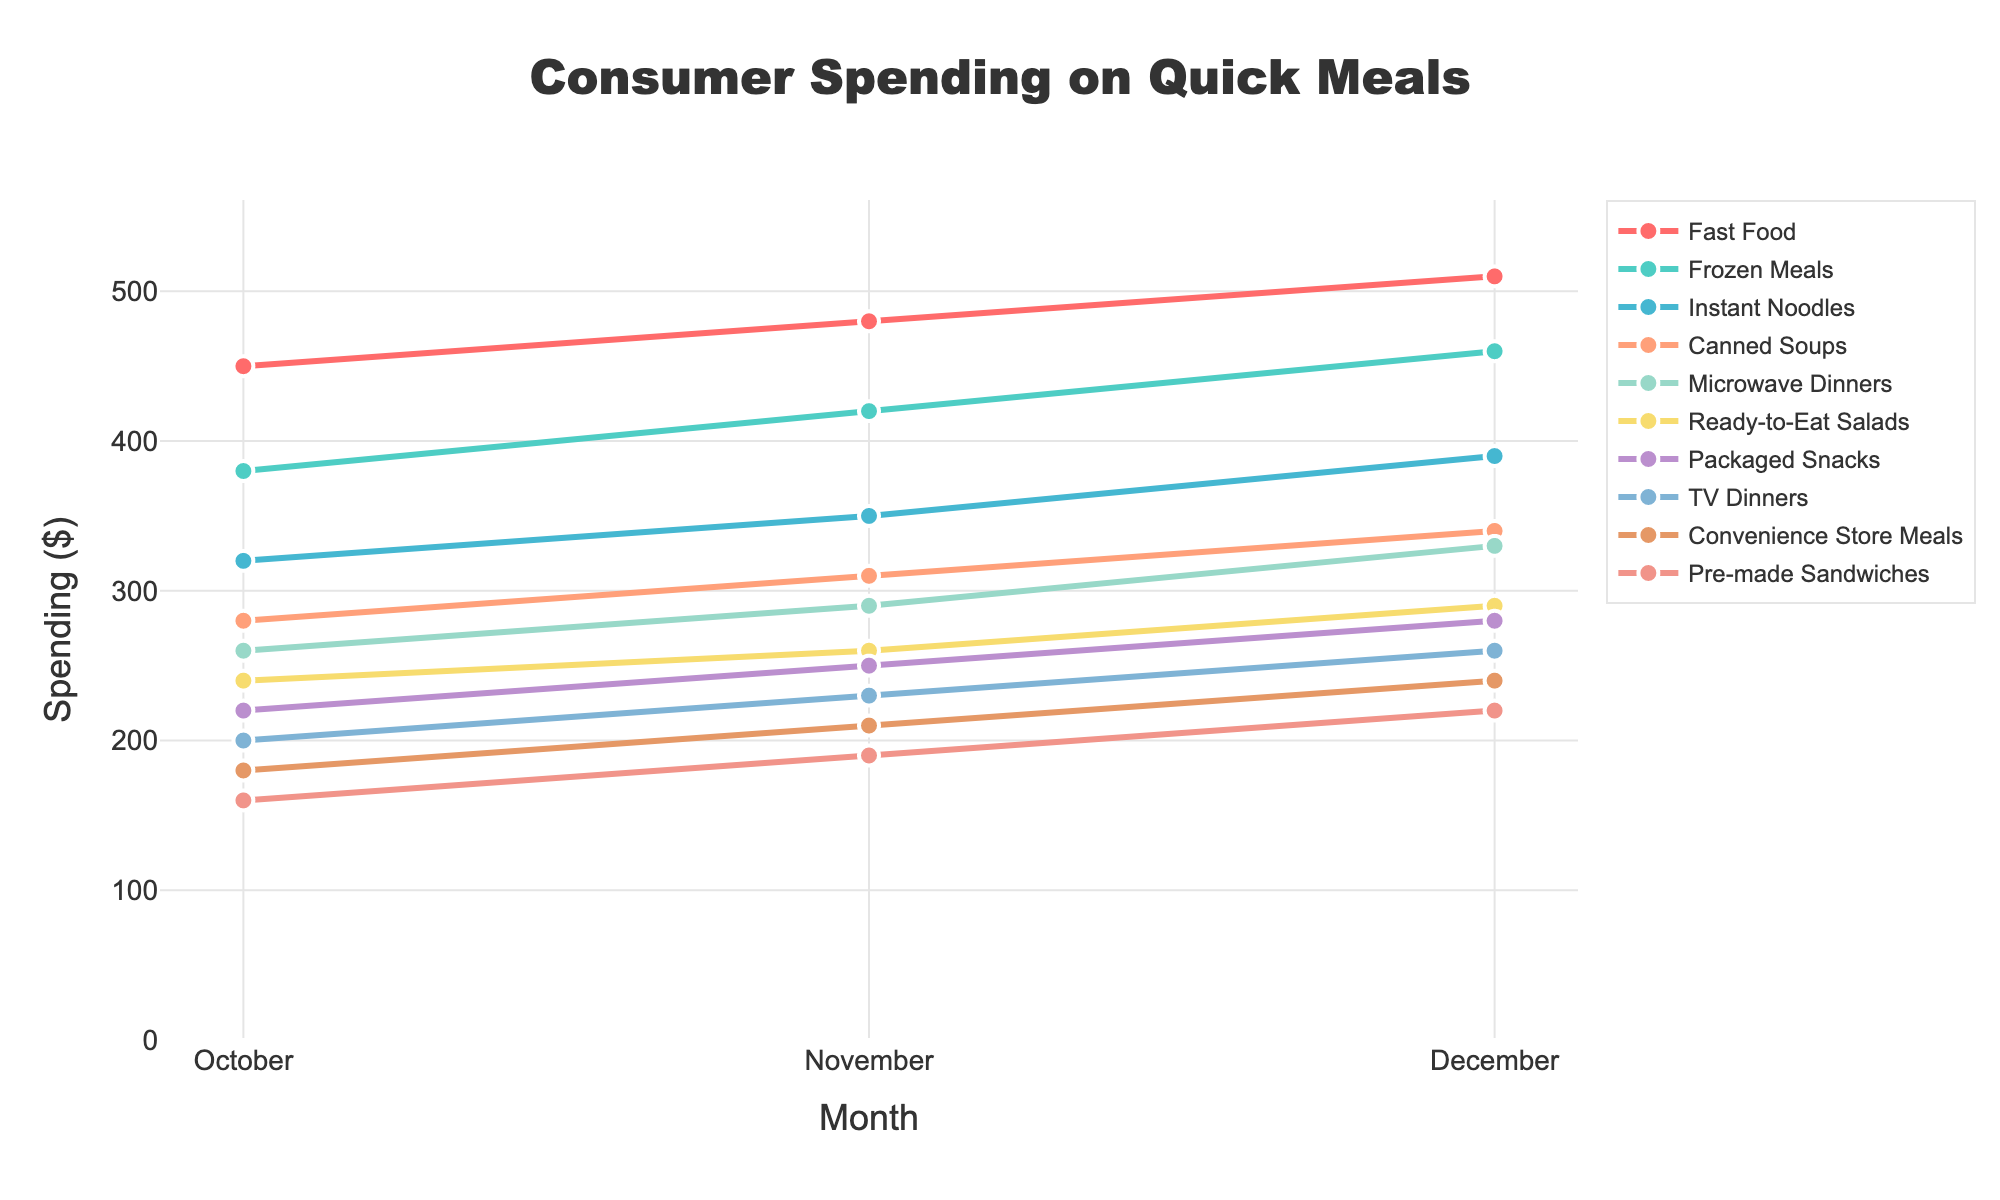What is the spending trend for Fast Food over the three months? The spending on Fast Food shows an increasing trend: in October, it is $450, in November, it is $480, and in December, it is $510.
Answer: Increasing Which cuisine type had the highest spending in December? By inspecting the values for December, we see that Fast Food had the highest spending at $510.
Answer: Fast Food Compare the total spending on Frozen Meals and Instant Noodles over the quarter. Which had more spending? To find the total spending: Frozen Meals = 380 + 420 + 460 = $1260, and Instant Noodles = 320 + 350 + 390 = $1060. Therefore, Frozen Meals had more spending.
Answer: Frozen Meals Which cuisine type had the lowest spending in October, and what was it? Pre-made Sandwiches had the lowest spending in October, which was $160.
Answer: Pre-made Sandwiches, $160 What is the change in spending for TV Dinners from October to December? The spending on TV Dinners in October was $200 and in December it was $260. The change is $260 - $200 = $60.
Answer: $60 How much more was spent on Canned Soups than on Packaged Snacks in November? The spending on Canned Soups in November was $310, and on Packaged Snacks it was $250. The difference is $310 - $250 = $60.
Answer: $60 If you average the spending of Microwave Dinners across the three months, what is the result? The spending for Microwave Dinners was $260 in October, $290 in November, and $330 in December. The average is (260 + 290 + 330) / 3 = $880 / 3 ≈ $293.33.
Answer: $293.33 Compare the overall spending trend between Ready-to-Eat Salads and Convenience Store Meals. Which shows a greater rate of increase? Ready-to-Eat Salads increased from $240 to $290, a $50 increase. Convenience Store Meals increased from $180 to $240, a $60 increase. Therefore, Convenience Store Meals shows a greater rate of increase.
Answer: Convenience Store Meals What is the total spending on all cuisine types in November? Sum of all spending in November: 480 (Fast Food) + 420 (Frozen Meals) + 350 (Instant Noodles) + 310 (Canned Soups) + 290 (Microwave Dinners) + 260 (Ready-to-Eat Salads) + 250 (Packaged Snacks) + 230 (TV Dinners) + 210 (Convenience Store Meals) + 190 (Pre-made Sandwiches) = 2990.
Answer: $2990 Identify the color used to represent Ready-to-Eat Salads. The color used for Ready-to-Eat Salads is a shade of yellow as per the color scale mentioned in the data.
Answer: Yellow 